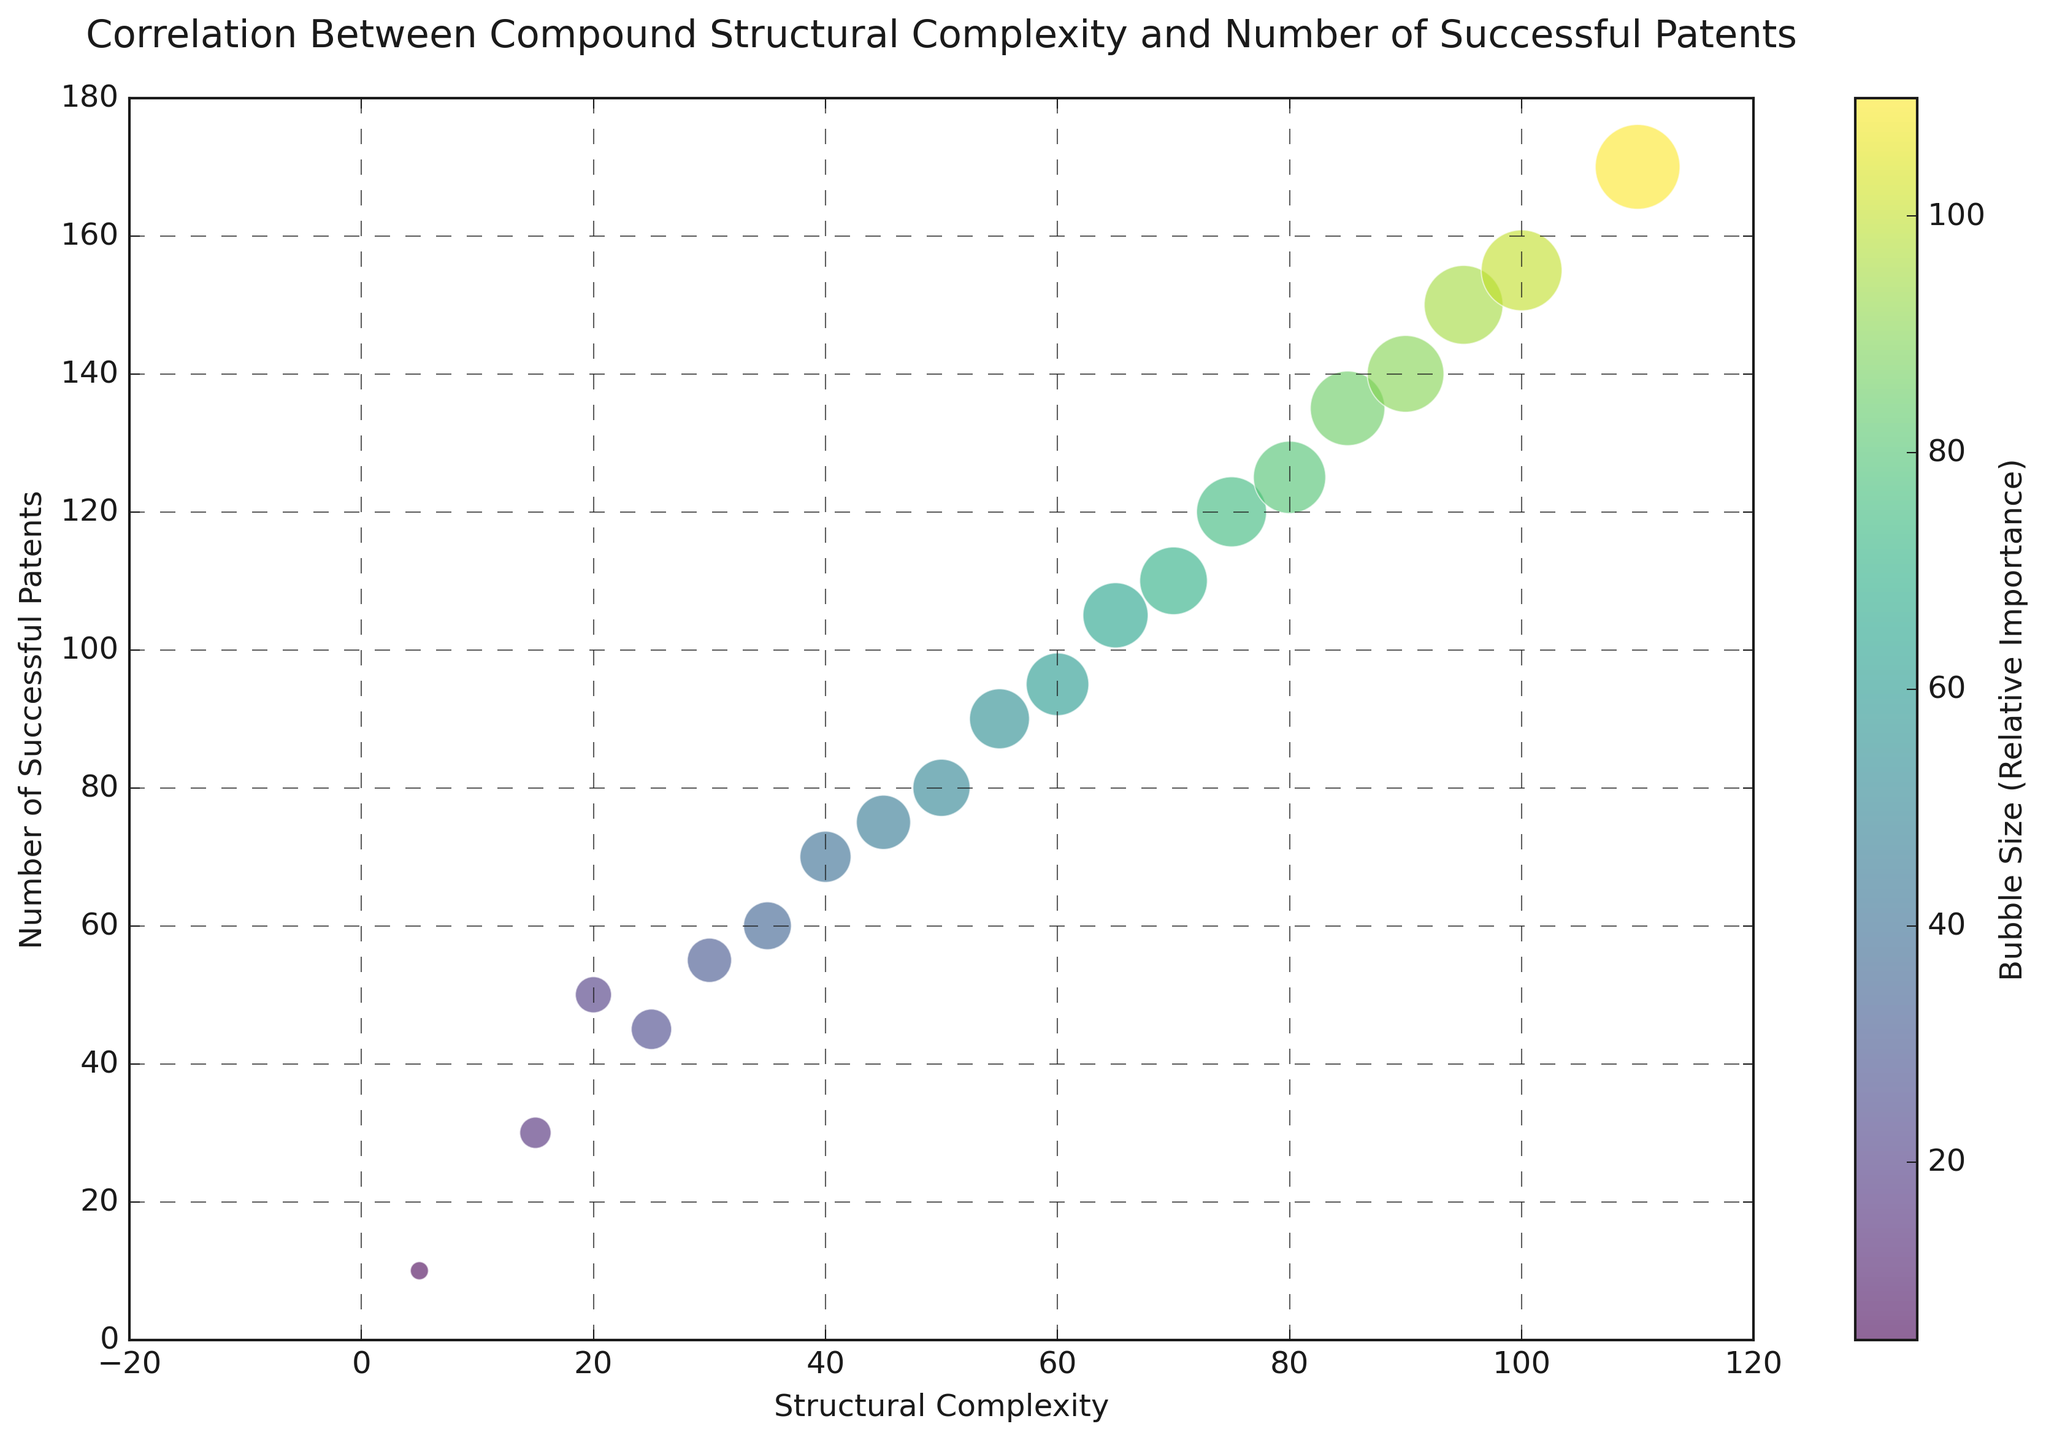What is the Structural Complexity value of the compound with the highest number of successful patents? The figure shows the correlation between Structural Complexity and Number of Successful Patents. By locating the compound with the highest number of successful patents on the y-axis, we see that the compound with 170 patents has a Structural Complexity of 110.
Answer: 110 Compare the number of successful patents between the simplest (Structural Complexity = 5) and the most complex (Structural Complexity = 110) compounds. In the figure, the simplest compound (Structural Complexity = 5) has 10 successful patents, while the most complex compound (Structural Complexity = 110) has 170 successful patents.
Answer: 10 vs. 170 What is the average number of successful patents for compounds with Structural Complexity values of 40, 50, and 60? The values for these compounds are 70, 80, and 95 successful patents respectively. The average is calculated as (70 + 80 + 95) / 3 = 245 / 3 = 81.67.
Answer: 81.67 Which compound has a larger bubble size: the compound with Structural Complexity of 30 or the compound with Structural Complexity of 75? By comparing the bubble sizes on the figure, it’s apparent that the compound with Structural Complexity of 75 has a larger bubble size than the one with Structural Complexity of 30.
Answer: Compound with Structural Complexity of 75 What does the color intensity represent in the figure? The color intensity in the figure indicates the bubble size, which is a measure of relative importance. Brighter colors correspond to larger bubble sizes and thus more importance, while duller colors correspond to smaller bubble sizes.
Answer: Bubble Size Is there a direct correlation between Structural Complexity and Number of Successful Patents evident from the figure? Yes, the figure shows a clear, positive correlation between the Structural Complexity and the Number of Successful Patents, as both values increase together consistently.
Answer: Yes What are the Structural Complexity values for compounds with exactly 80 and 95 successful patents? By locating the points on the y-axis and moving horizontally to the x-axis, the Structural Complexity values for compounds with 80 and 95 successful patents are 50 and 60, respectively.
Answer: 50 and 60 